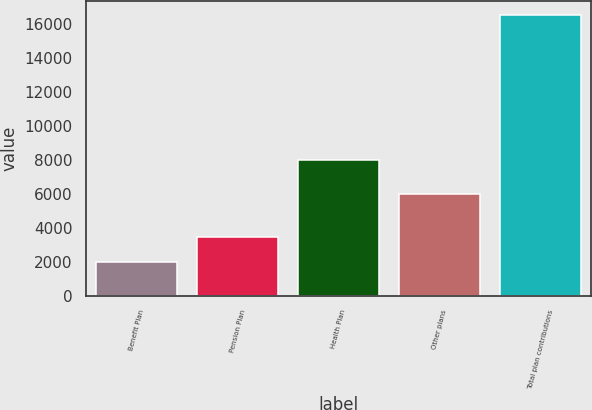Convert chart. <chart><loc_0><loc_0><loc_500><loc_500><bar_chart><fcel>Benefit Plan<fcel>Pension Plan<fcel>Health Plan<fcel>Other plans<fcel>Total plan contributions<nl><fcel>2012<fcel>3465.9<fcel>8020<fcel>6025<fcel>16551<nl></chart> 